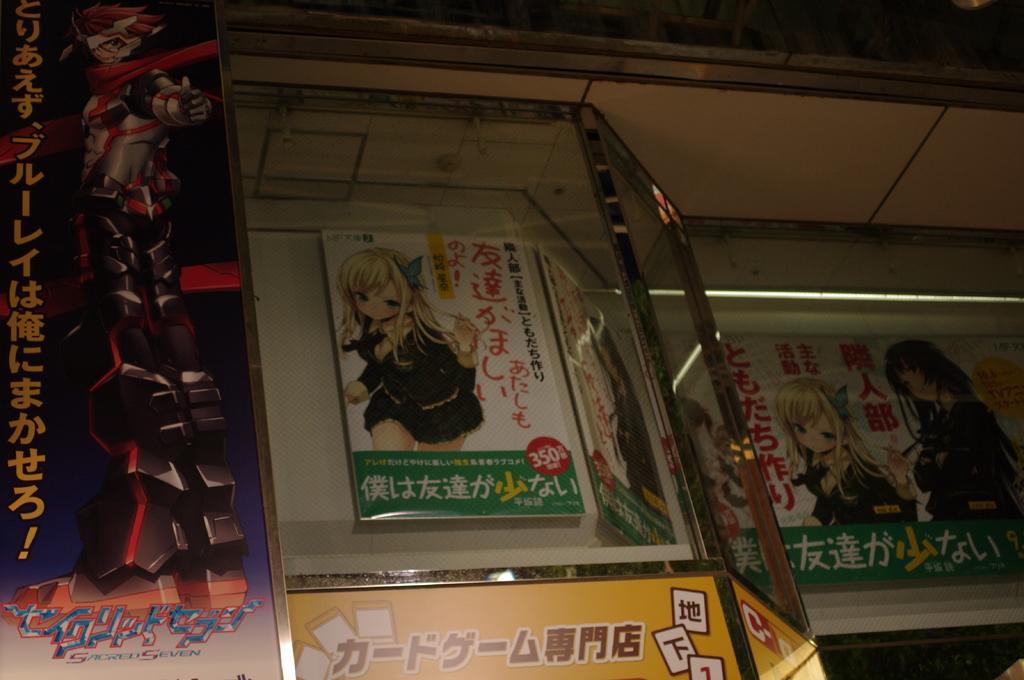How would you summarize this image in a sentence or two? In the image we can see a poster and a glass window. This is a light, in the poster we can see an animated image of a girl wearing clothes. This is a text. 